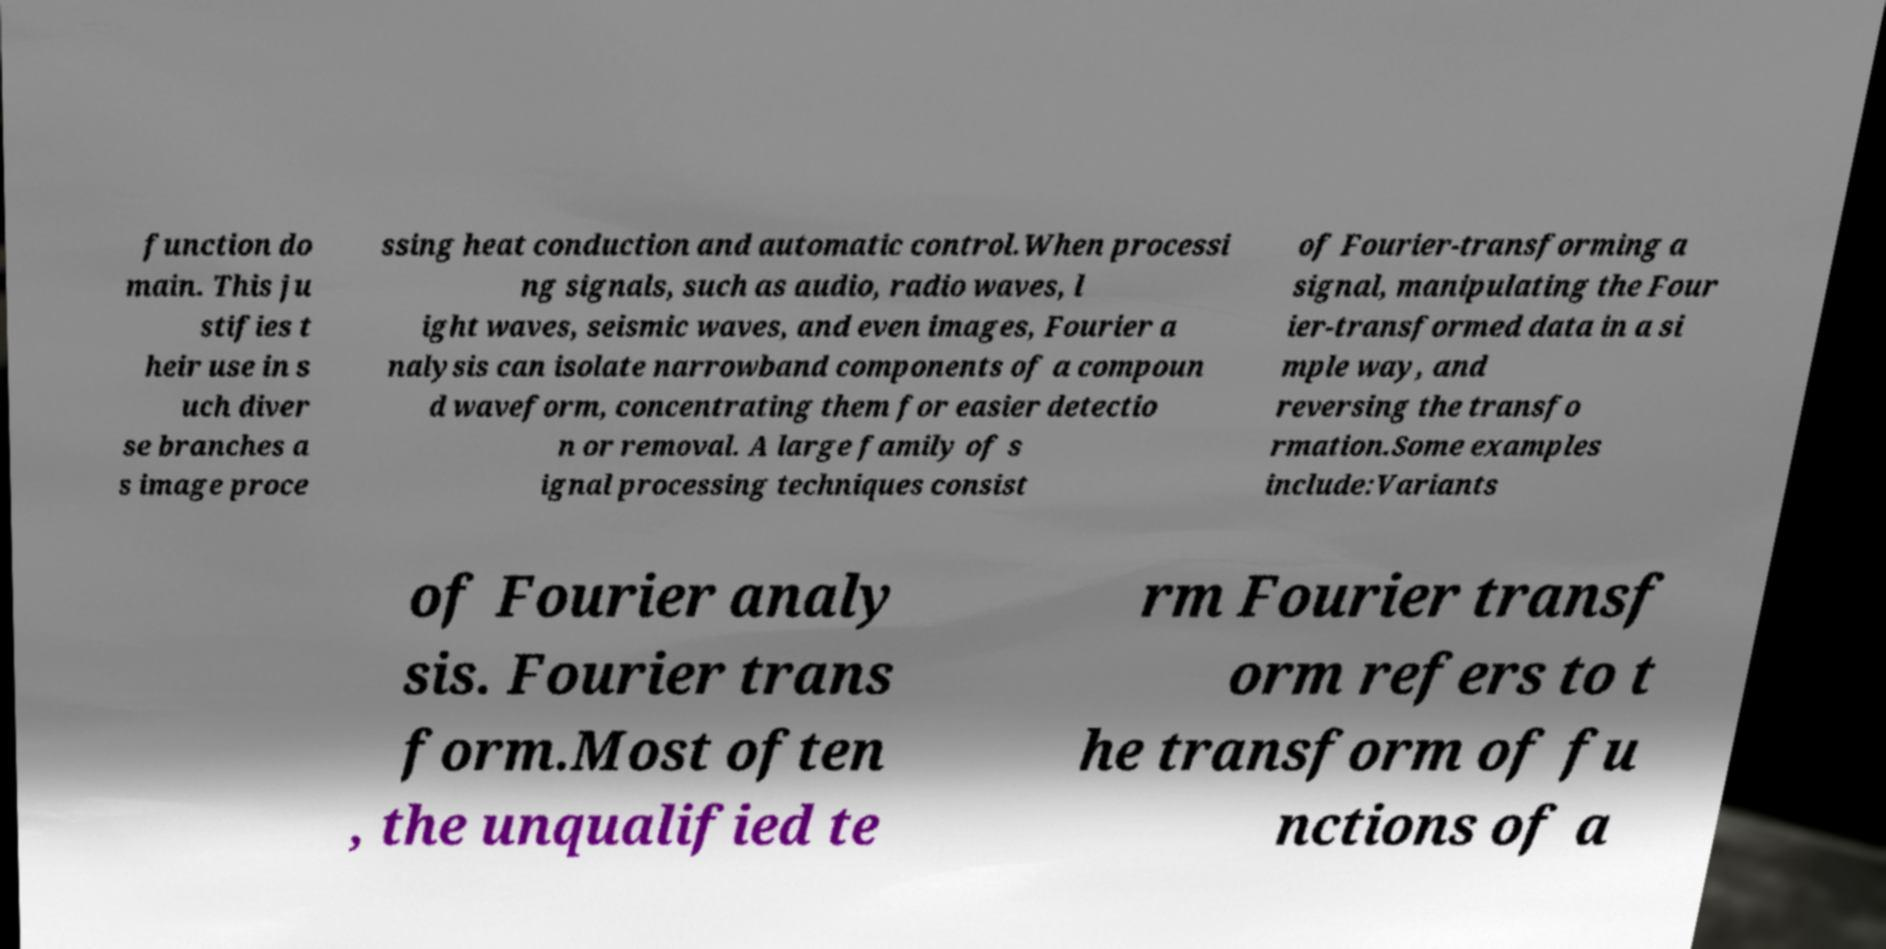For documentation purposes, I need the text within this image transcribed. Could you provide that? function do main. This ju stifies t heir use in s uch diver se branches a s image proce ssing heat conduction and automatic control.When processi ng signals, such as audio, radio waves, l ight waves, seismic waves, and even images, Fourier a nalysis can isolate narrowband components of a compoun d waveform, concentrating them for easier detectio n or removal. A large family of s ignal processing techniques consist of Fourier-transforming a signal, manipulating the Four ier-transformed data in a si mple way, and reversing the transfo rmation.Some examples include:Variants of Fourier analy sis. Fourier trans form.Most often , the unqualified te rm Fourier transf orm refers to t he transform of fu nctions of a 